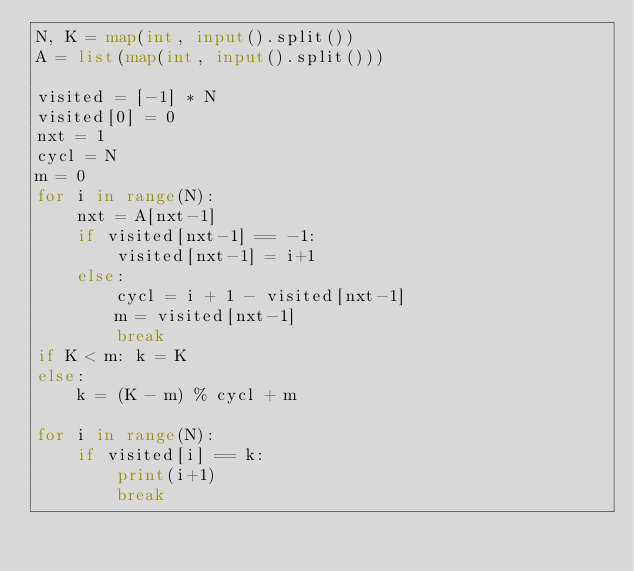Convert code to text. <code><loc_0><loc_0><loc_500><loc_500><_Python_>N, K = map(int, input().split())
A = list(map(int, input().split()))

visited = [-1] * N
visited[0] = 0
nxt = 1
cycl = N
m = 0
for i in range(N):
    nxt = A[nxt-1]
    if visited[nxt-1] == -1:
        visited[nxt-1] = i+1
    else:
        cycl = i + 1 - visited[nxt-1]
        m = visited[nxt-1]
        break
if K < m: k = K
else:
    k = (K - m) % cycl + m

for i in range(N):
    if visited[i] == k:
        print(i+1)
        break
</code> 